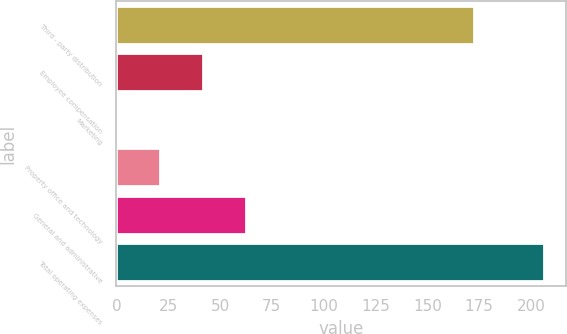Convert chart to OTSL. <chart><loc_0><loc_0><loc_500><loc_500><bar_chart><fcel>Third - party distribution<fcel>Employee compensation<fcel>Marketing<fcel>Property office and technology<fcel>General and administrative<fcel>Total operating expenses<nl><fcel>172.7<fcel>41.78<fcel>0.6<fcel>21.19<fcel>62.37<fcel>206.5<nl></chart> 